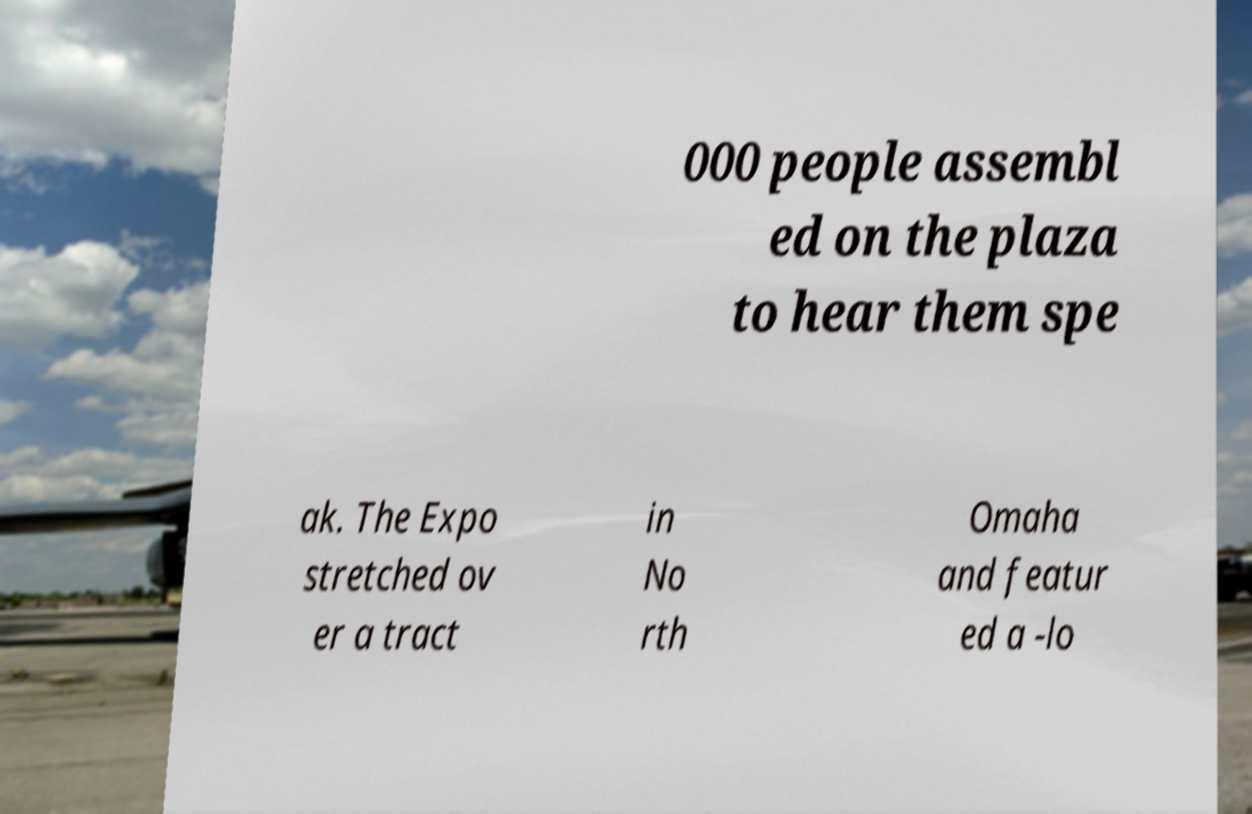What messages or text are displayed in this image? I need them in a readable, typed format. 000 people assembl ed on the plaza to hear them spe ak. The Expo stretched ov er a tract in No rth Omaha and featur ed a -lo 